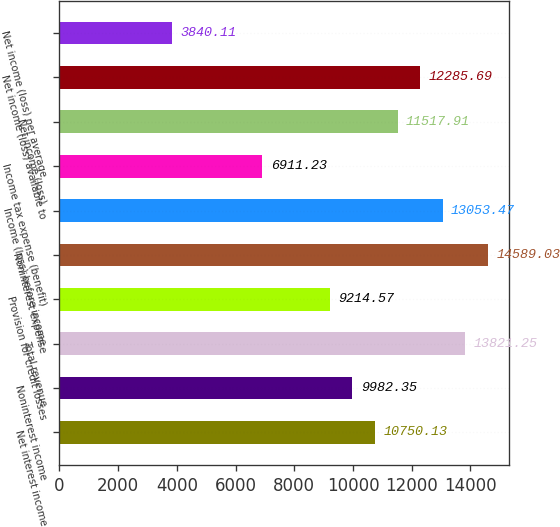<chart> <loc_0><loc_0><loc_500><loc_500><bar_chart><fcel>Net interest income<fcel>Noninterest income<fcel>Total revenue<fcel>Provision for credit losses<fcel>Noninterest expense<fcel>Income (loss) before income<fcel>Income tax expense (benefit)<fcel>Net income (loss)<fcel>Net income (loss) available to<fcel>Net income (loss) per average<nl><fcel>10750.1<fcel>9982.35<fcel>13821.2<fcel>9214.57<fcel>14589<fcel>13053.5<fcel>6911.23<fcel>11517.9<fcel>12285.7<fcel>3840.11<nl></chart> 